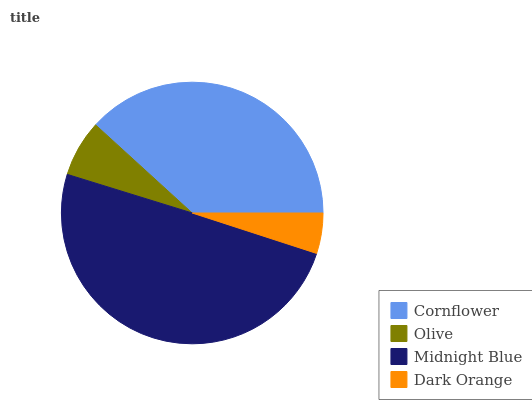Is Dark Orange the minimum?
Answer yes or no. Yes. Is Midnight Blue the maximum?
Answer yes or no. Yes. Is Olive the minimum?
Answer yes or no. No. Is Olive the maximum?
Answer yes or no. No. Is Cornflower greater than Olive?
Answer yes or no. Yes. Is Olive less than Cornflower?
Answer yes or no. Yes. Is Olive greater than Cornflower?
Answer yes or no. No. Is Cornflower less than Olive?
Answer yes or no. No. Is Cornflower the high median?
Answer yes or no. Yes. Is Olive the low median?
Answer yes or no. Yes. Is Olive the high median?
Answer yes or no. No. Is Midnight Blue the low median?
Answer yes or no. No. 